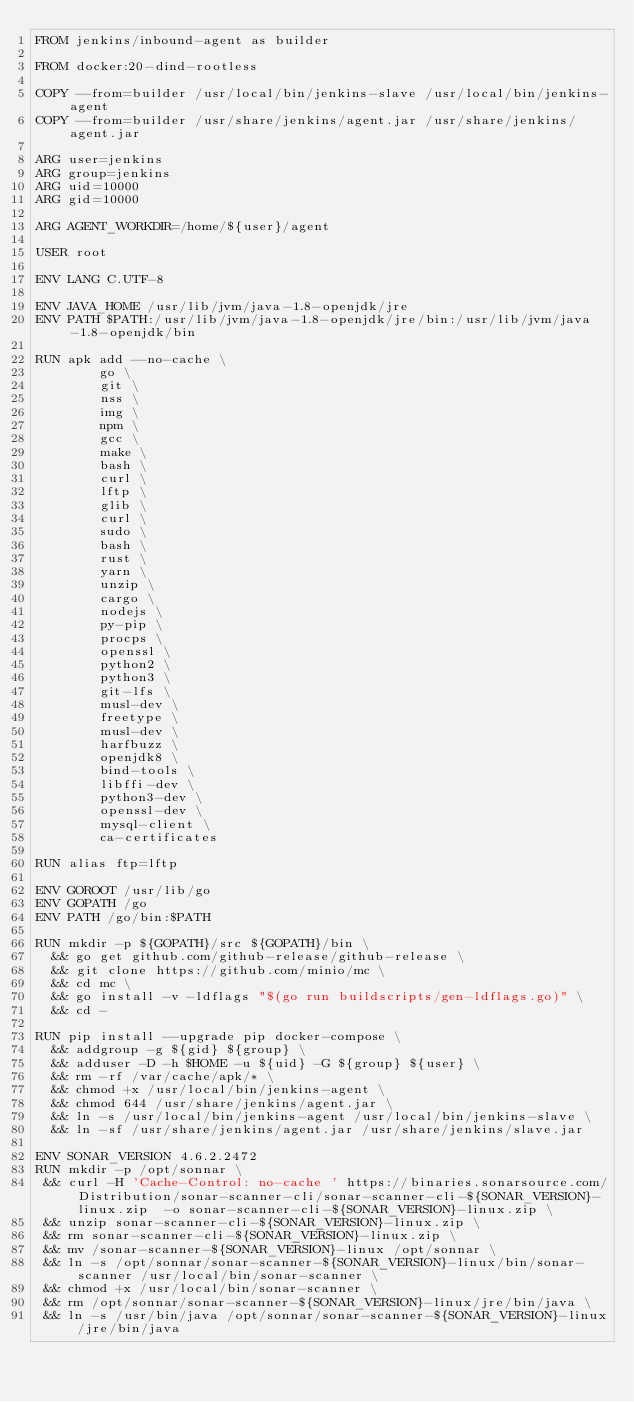Convert code to text. <code><loc_0><loc_0><loc_500><loc_500><_Dockerfile_>FROM jenkins/inbound-agent as builder

FROM docker:20-dind-rootless

COPY --from=builder /usr/local/bin/jenkins-slave /usr/local/bin/jenkins-agent
COPY --from=builder /usr/share/jenkins/agent.jar /usr/share/jenkins/agent.jar

ARG user=jenkins
ARG group=jenkins
ARG uid=10000
ARG gid=10000

ARG AGENT_WORKDIR=/home/${user}/agent

USER root

ENV LANG C.UTF-8

ENV JAVA_HOME /usr/lib/jvm/java-1.8-openjdk/jre
ENV PATH $PATH:/usr/lib/jvm/java-1.8-openjdk/jre/bin:/usr/lib/jvm/java-1.8-openjdk/bin

RUN apk add --no-cache \
        go \
        git \
        nss \
        img \
        npm \
        gcc \
        make \
        bash \
        curl \
        lftp \
        glib \
        curl \
        sudo \
        bash \
        rust \
        yarn \
        unzip \
        cargo \
        nodejs \
        py-pip \
        procps \
        openssl \
        python2 \
        python3 \
        git-lfs \
        musl-dev \
        freetype \
        musl-dev \
        harfbuzz \
        openjdk8 \
        bind-tools \
        libffi-dev \
        python3-dev \
        openssl-dev \
        mysql-client \
        ca-certificates 

RUN alias ftp=lftp

ENV GOROOT /usr/lib/go
ENV GOPATH /go
ENV PATH /go/bin:$PATH

RUN mkdir -p ${GOPATH}/src ${GOPATH}/bin \
  && go get github.com/github-release/github-release \
  && git clone https://github.com/minio/mc \
  && cd mc \
  && go install -v -ldflags "$(go run buildscripts/gen-ldflags.go)" \ 
  && cd -

RUN pip install --upgrade pip docker-compose \
  && addgroup -g ${gid} ${group} \
  && adduser -D -h $HOME -u ${uid} -G ${group} ${user} \
  && rm -rf /var/cache/apk/* \
  && chmod +x /usr/local/bin/jenkins-agent \
  && chmod 644 /usr/share/jenkins/agent.jar \
  && ln -s /usr/local/bin/jenkins-agent /usr/local/bin/jenkins-slave \
  && ln -sf /usr/share/jenkins/agent.jar /usr/share/jenkins/slave.jar 

ENV SONAR_VERSION 4.6.2.2472
RUN mkdir -p /opt/sonnar \
 && curl -H 'Cache-Control: no-cache ' https://binaries.sonarsource.com/Distribution/sonar-scanner-cli/sonar-scanner-cli-${SONAR_VERSION}-linux.zip  -o sonar-scanner-cli-${SONAR_VERSION}-linux.zip \
 && unzip sonar-scanner-cli-${SONAR_VERSION}-linux.zip \
 && rm sonar-scanner-cli-${SONAR_VERSION}-linux.zip \
 && mv /sonar-scanner-${SONAR_VERSION}-linux /opt/sonnar \
 && ln -s /opt/sonnar/sonar-scanner-${SONAR_VERSION}-linux/bin/sonar-scanner /usr/local/bin/sonar-scanner \
 && chmod +x /usr/local/bin/sonar-scanner \
 && rm /opt/sonnar/sonar-scanner-${SONAR_VERSION}-linux/jre/bin/java \
 && ln -s /usr/bin/java /opt/sonnar/sonar-scanner-${SONAR_VERSION}-linux/jre/bin/java
</code> 